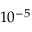<formula> <loc_0><loc_0><loc_500><loc_500>1 0 ^ { - 5 }</formula> 